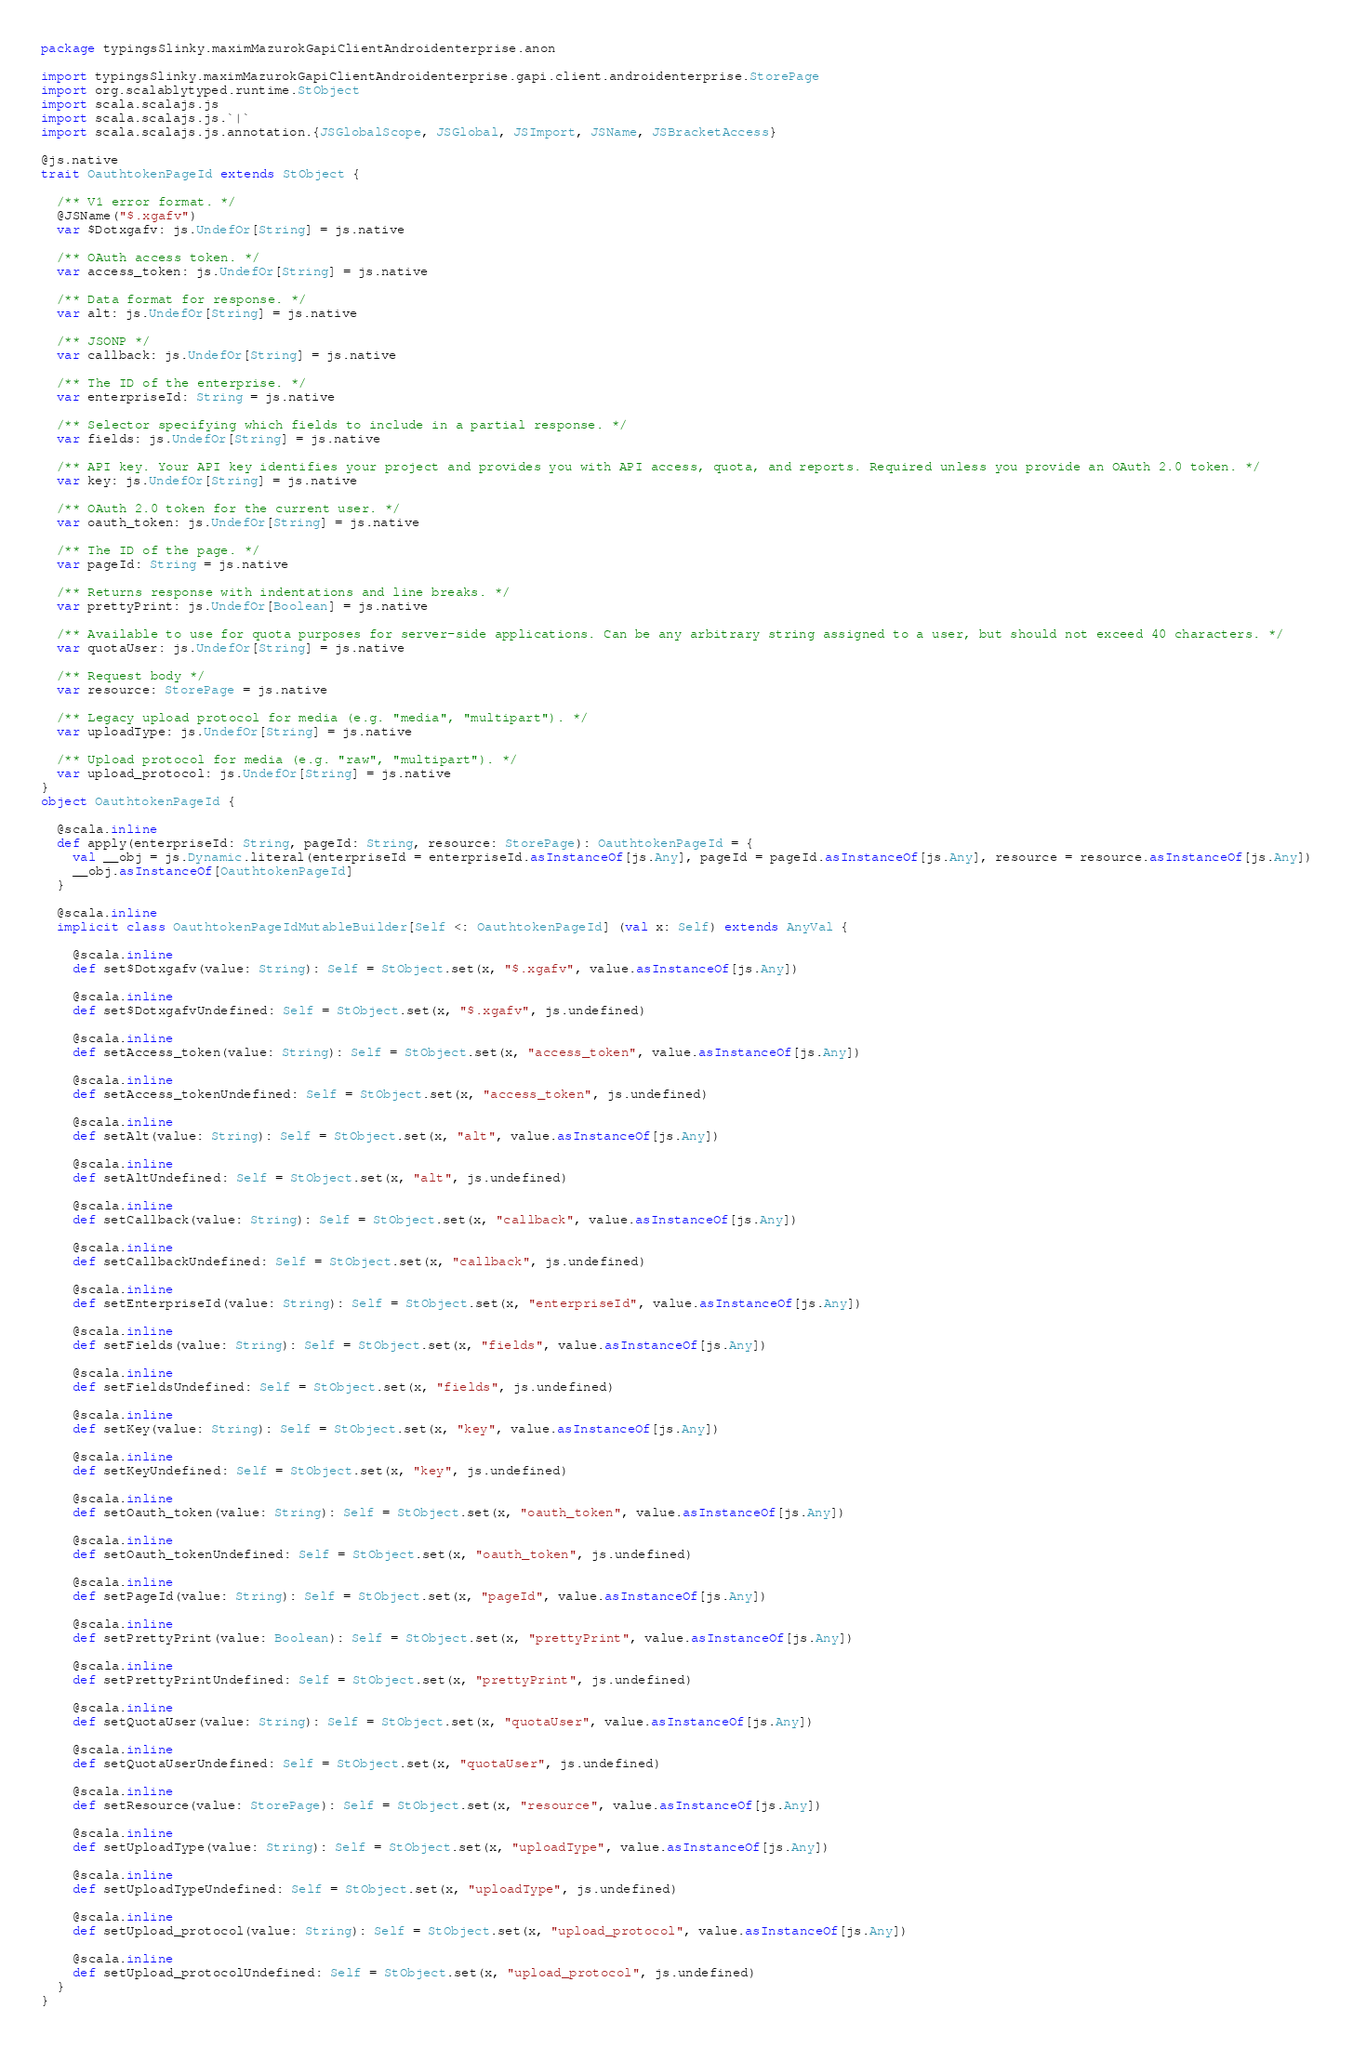Convert code to text. <code><loc_0><loc_0><loc_500><loc_500><_Scala_>package typingsSlinky.maximMazurokGapiClientAndroidenterprise.anon

import typingsSlinky.maximMazurokGapiClientAndroidenterprise.gapi.client.androidenterprise.StorePage
import org.scalablytyped.runtime.StObject
import scala.scalajs.js
import scala.scalajs.js.`|`
import scala.scalajs.js.annotation.{JSGlobalScope, JSGlobal, JSImport, JSName, JSBracketAccess}

@js.native
trait OauthtokenPageId extends StObject {
  
  /** V1 error format. */
  @JSName("$.xgafv")
  var $Dotxgafv: js.UndefOr[String] = js.native
  
  /** OAuth access token. */
  var access_token: js.UndefOr[String] = js.native
  
  /** Data format for response. */
  var alt: js.UndefOr[String] = js.native
  
  /** JSONP */
  var callback: js.UndefOr[String] = js.native
  
  /** The ID of the enterprise. */
  var enterpriseId: String = js.native
  
  /** Selector specifying which fields to include in a partial response. */
  var fields: js.UndefOr[String] = js.native
  
  /** API key. Your API key identifies your project and provides you with API access, quota, and reports. Required unless you provide an OAuth 2.0 token. */
  var key: js.UndefOr[String] = js.native
  
  /** OAuth 2.0 token for the current user. */
  var oauth_token: js.UndefOr[String] = js.native
  
  /** The ID of the page. */
  var pageId: String = js.native
  
  /** Returns response with indentations and line breaks. */
  var prettyPrint: js.UndefOr[Boolean] = js.native
  
  /** Available to use for quota purposes for server-side applications. Can be any arbitrary string assigned to a user, but should not exceed 40 characters. */
  var quotaUser: js.UndefOr[String] = js.native
  
  /** Request body */
  var resource: StorePage = js.native
  
  /** Legacy upload protocol for media (e.g. "media", "multipart"). */
  var uploadType: js.UndefOr[String] = js.native
  
  /** Upload protocol for media (e.g. "raw", "multipart"). */
  var upload_protocol: js.UndefOr[String] = js.native
}
object OauthtokenPageId {
  
  @scala.inline
  def apply(enterpriseId: String, pageId: String, resource: StorePage): OauthtokenPageId = {
    val __obj = js.Dynamic.literal(enterpriseId = enterpriseId.asInstanceOf[js.Any], pageId = pageId.asInstanceOf[js.Any], resource = resource.asInstanceOf[js.Any])
    __obj.asInstanceOf[OauthtokenPageId]
  }
  
  @scala.inline
  implicit class OauthtokenPageIdMutableBuilder[Self <: OauthtokenPageId] (val x: Self) extends AnyVal {
    
    @scala.inline
    def set$Dotxgafv(value: String): Self = StObject.set(x, "$.xgafv", value.asInstanceOf[js.Any])
    
    @scala.inline
    def set$DotxgafvUndefined: Self = StObject.set(x, "$.xgafv", js.undefined)
    
    @scala.inline
    def setAccess_token(value: String): Self = StObject.set(x, "access_token", value.asInstanceOf[js.Any])
    
    @scala.inline
    def setAccess_tokenUndefined: Self = StObject.set(x, "access_token", js.undefined)
    
    @scala.inline
    def setAlt(value: String): Self = StObject.set(x, "alt", value.asInstanceOf[js.Any])
    
    @scala.inline
    def setAltUndefined: Self = StObject.set(x, "alt", js.undefined)
    
    @scala.inline
    def setCallback(value: String): Self = StObject.set(x, "callback", value.asInstanceOf[js.Any])
    
    @scala.inline
    def setCallbackUndefined: Self = StObject.set(x, "callback", js.undefined)
    
    @scala.inline
    def setEnterpriseId(value: String): Self = StObject.set(x, "enterpriseId", value.asInstanceOf[js.Any])
    
    @scala.inline
    def setFields(value: String): Self = StObject.set(x, "fields", value.asInstanceOf[js.Any])
    
    @scala.inline
    def setFieldsUndefined: Self = StObject.set(x, "fields", js.undefined)
    
    @scala.inline
    def setKey(value: String): Self = StObject.set(x, "key", value.asInstanceOf[js.Any])
    
    @scala.inline
    def setKeyUndefined: Self = StObject.set(x, "key", js.undefined)
    
    @scala.inline
    def setOauth_token(value: String): Self = StObject.set(x, "oauth_token", value.asInstanceOf[js.Any])
    
    @scala.inline
    def setOauth_tokenUndefined: Self = StObject.set(x, "oauth_token", js.undefined)
    
    @scala.inline
    def setPageId(value: String): Self = StObject.set(x, "pageId", value.asInstanceOf[js.Any])
    
    @scala.inline
    def setPrettyPrint(value: Boolean): Self = StObject.set(x, "prettyPrint", value.asInstanceOf[js.Any])
    
    @scala.inline
    def setPrettyPrintUndefined: Self = StObject.set(x, "prettyPrint", js.undefined)
    
    @scala.inline
    def setQuotaUser(value: String): Self = StObject.set(x, "quotaUser", value.asInstanceOf[js.Any])
    
    @scala.inline
    def setQuotaUserUndefined: Self = StObject.set(x, "quotaUser", js.undefined)
    
    @scala.inline
    def setResource(value: StorePage): Self = StObject.set(x, "resource", value.asInstanceOf[js.Any])
    
    @scala.inline
    def setUploadType(value: String): Self = StObject.set(x, "uploadType", value.asInstanceOf[js.Any])
    
    @scala.inline
    def setUploadTypeUndefined: Self = StObject.set(x, "uploadType", js.undefined)
    
    @scala.inline
    def setUpload_protocol(value: String): Self = StObject.set(x, "upload_protocol", value.asInstanceOf[js.Any])
    
    @scala.inline
    def setUpload_protocolUndefined: Self = StObject.set(x, "upload_protocol", js.undefined)
  }
}
</code> 